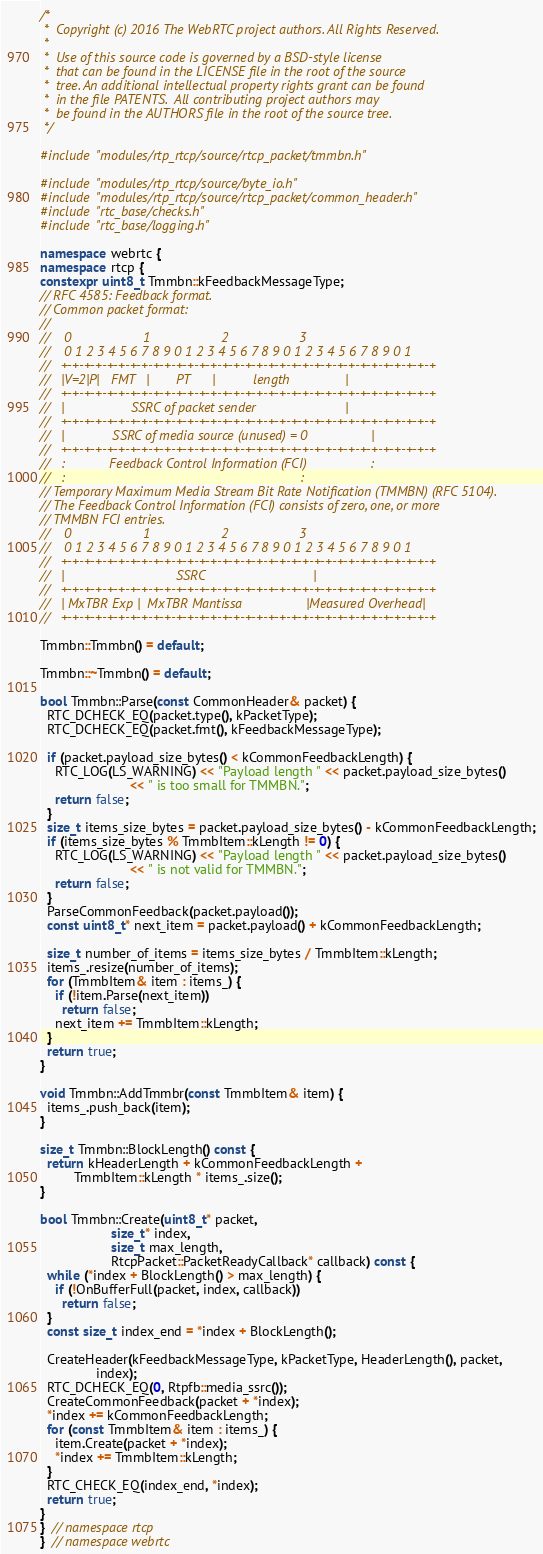<code> <loc_0><loc_0><loc_500><loc_500><_C++_>/*
 *  Copyright (c) 2016 The WebRTC project authors. All Rights Reserved.
 *
 *  Use of this source code is governed by a BSD-style license
 *  that can be found in the LICENSE file in the root of the source
 *  tree. An additional intellectual property rights grant can be found
 *  in the file PATENTS.  All contributing project authors may
 *  be found in the AUTHORS file in the root of the source tree.
 */

#include "modules/rtp_rtcp/source/rtcp_packet/tmmbn.h"

#include "modules/rtp_rtcp/source/byte_io.h"
#include "modules/rtp_rtcp/source/rtcp_packet/common_header.h"
#include "rtc_base/checks.h"
#include "rtc_base/logging.h"

namespace webrtc {
namespace rtcp {
constexpr uint8_t Tmmbn::kFeedbackMessageType;
// RFC 4585: Feedback format.
// Common packet format:
//
//    0                   1                   2                   3
//    0 1 2 3 4 5 6 7 8 9 0 1 2 3 4 5 6 7 8 9 0 1 2 3 4 5 6 7 8 9 0 1
//   +-+-+-+-+-+-+-+-+-+-+-+-+-+-+-+-+-+-+-+-+-+-+-+-+-+-+-+-+-+-+-+-+
//   |V=2|P|   FMT   |       PT      |          length               |
//   +-+-+-+-+-+-+-+-+-+-+-+-+-+-+-+-+-+-+-+-+-+-+-+-+-+-+-+-+-+-+-+-+
//   |                  SSRC of packet sender                        |
//   +-+-+-+-+-+-+-+-+-+-+-+-+-+-+-+-+-+-+-+-+-+-+-+-+-+-+-+-+-+-+-+-+
//   |             SSRC of media source (unused) = 0                 |
//   +-+-+-+-+-+-+-+-+-+-+-+-+-+-+-+-+-+-+-+-+-+-+-+-+-+-+-+-+-+-+-+-+
//   :            Feedback Control Information (FCI)                 :
//   :                                                               :
// Temporary Maximum Media Stream Bit Rate Notification (TMMBN) (RFC 5104).
// The Feedback Control Information (FCI) consists of zero, one, or more
// TMMBN FCI entries.
//    0                   1                   2                   3
//    0 1 2 3 4 5 6 7 8 9 0 1 2 3 4 5 6 7 8 9 0 1 2 3 4 5 6 7 8 9 0 1
//   +-+-+-+-+-+-+-+-+-+-+-+-+-+-+-+-+-+-+-+-+-+-+-+-+-+-+-+-+-+-+-+-+
//   |                              SSRC                             |
//   +-+-+-+-+-+-+-+-+-+-+-+-+-+-+-+-+-+-+-+-+-+-+-+-+-+-+-+-+-+-+-+-+
//   | MxTBR Exp |  MxTBR Mantissa                 |Measured Overhead|
//   +-+-+-+-+-+-+-+-+-+-+-+-+-+-+-+-+-+-+-+-+-+-+-+-+-+-+-+-+-+-+-+-+

Tmmbn::Tmmbn() = default;

Tmmbn::~Tmmbn() = default;

bool Tmmbn::Parse(const CommonHeader& packet) {
  RTC_DCHECK_EQ(packet.type(), kPacketType);
  RTC_DCHECK_EQ(packet.fmt(), kFeedbackMessageType);

  if (packet.payload_size_bytes() < kCommonFeedbackLength) {
    RTC_LOG(LS_WARNING) << "Payload length " << packet.payload_size_bytes()
                        << " is too small for TMMBN.";
    return false;
  }
  size_t items_size_bytes = packet.payload_size_bytes() - kCommonFeedbackLength;
  if (items_size_bytes % TmmbItem::kLength != 0) {
    RTC_LOG(LS_WARNING) << "Payload length " << packet.payload_size_bytes()
                        << " is not valid for TMMBN.";
    return false;
  }
  ParseCommonFeedback(packet.payload());
  const uint8_t* next_item = packet.payload() + kCommonFeedbackLength;

  size_t number_of_items = items_size_bytes / TmmbItem::kLength;
  items_.resize(number_of_items);
  for (TmmbItem& item : items_) {
    if (!item.Parse(next_item))
      return false;
    next_item += TmmbItem::kLength;
  }
  return true;
}

void Tmmbn::AddTmmbr(const TmmbItem& item) {
  items_.push_back(item);
}

size_t Tmmbn::BlockLength() const {
  return kHeaderLength + kCommonFeedbackLength +
         TmmbItem::kLength * items_.size();
}

bool Tmmbn::Create(uint8_t* packet,
                   size_t* index,
                   size_t max_length,
                   RtcpPacket::PacketReadyCallback* callback) const {
  while (*index + BlockLength() > max_length) {
    if (!OnBufferFull(packet, index, callback))
      return false;
  }
  const size_t index_end = *index + BlockLength();

  CreateHeader(kFeedbackMessageType, kPacketType, HeaderLength(), packet,
               index);
  RTC_DCHECK_EQ(0, Rtpfb::media_ssrc());
  CreateCommonFeedback(packet + *index);
  *index += kCommonFeedbackLength;
  for (const TmmbItem& item : items_) {
    item.Create(packet + *index);
    *index += TmmbItem::kLength;
  }
  RTC_CHECK_EQ(index_end, *index);
  return true;
}
}  // namespace rtcp
}  // namespace webrtc
</code> 